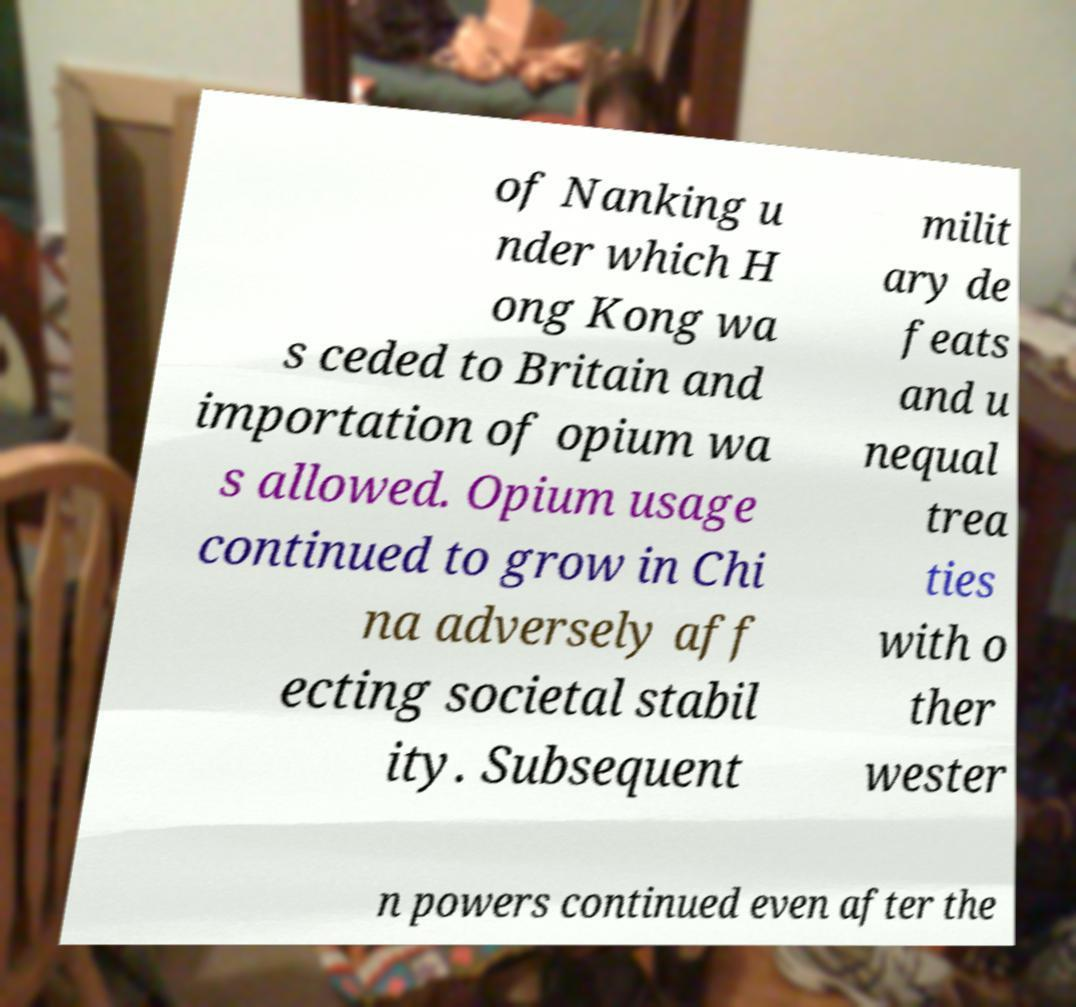There's text embedded in this image that I need extracted. Can you transcribe it verbatim? of Nanking u nder which H ong Kong wa s ceded to Britain and importation of opium wa s allowed. Opium usage continued to grow in Chi na adversely aff ecting societal stabil ity. Subsequent milit ary de feats and u nequal trea ties with o ther wester n powers continued even after the 